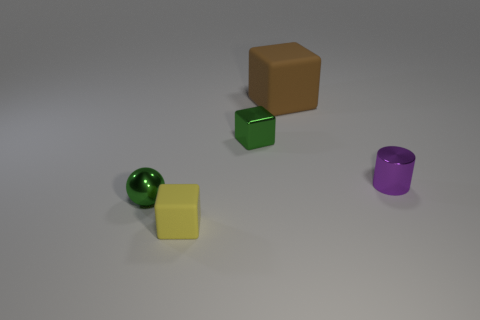Subtract all tiny yellow matte blocks. How many blocks are left? 2 Add 2 green blocks. How many objects exist? 7 Subtract all cylinders. How many objects are left? 4 Add 4 small yellow things. How many small yellow things are left? 5 Add 3 green metal things. How many green metal things exist? 5 Subtract all yellow blocks. How many blocks are left? 2 Subtract 0 purple blocks. How many objects are left? 5 Subtract 1 cubes. How many cubes are left? 2 Subtract all red balls. Subtract all purple cylinders. How many balls are left? 1 Subtract all gray cubes. How many purple balls are left? 0 